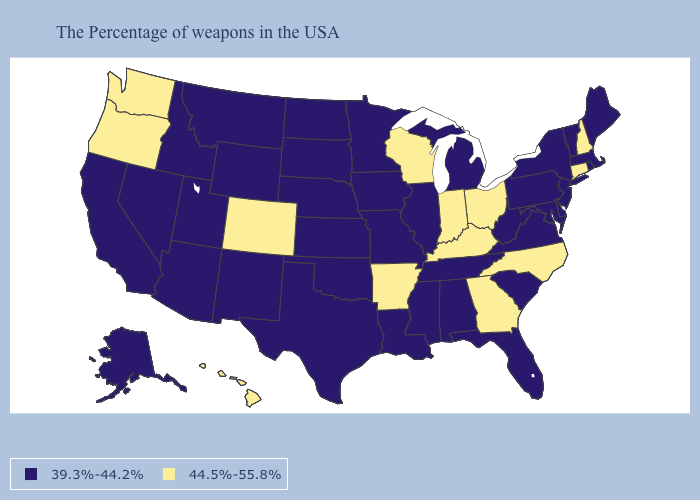What is the highest value in the Northeast ?
Give a very brief answer. 44.5%-55.8%. What is the highest value in states that border Texas?
Write a very short answer. 44.5%-55.8%. Which states have the highest value in the USA?
Keep it brief. New Hampshire, Connecticut, North Carolina, Ohio, Georgia, Kentucky, Indiana, Wisconsin, Arkansas, Colorado, Washington, Oregon, Hawaii. Which states have the highest value in the USA?
Be succinct. New Hampshire, Connecticut, North Carolina, Ohio, Georgia, Kentucky, Indiana, Wisconsin, Arkansas, Colorado, Washington, Oregon, Hawaii. What is the value of Arkansas?
Concise answer only. 44.5%-55.8%. Does Alabama have the highest value in the South?
Answer briefly. No. Among the states that border New Mexico , does Colorado have the lowest value?
Write a very short answer. No. What is the lowest value in states that border Rhode Island?
Short answer required. 39.3%-44.2%. What is the value of Alabama?
Short answer required. 39.3%-44.2%. Name the states that have a value in the range 44.5%-55.8%?
Short answer required. New Hampshire, Connecticut, North Carolina, Ohio, Georgia, Kentucky, Indiana, Wisconsin, Arkansas, Colorado, Washington, Oregon, Hawaii. What is the value of Florida?
Short answer required. 39.3%-44.2%. What is the highest value in the South ?
Answer briefly. 44.5%-55.8%. What is the value of Montana?
Short answer required. 39.3%-44.2%. Name the states that have a value in the range 39.3%-44.2%?
Short answer required. Maine, Massachusetts, Rhode Island, Vermont, New York, New Jersey, Delaware, Maryland, Pennsylvania, Virginia, South Carolina, West Virginia, Florida, Michigan, Alabama, Tennessee, Illinois, Mississippi, Louisiana, Missouri, Minnesota, Iowa, Kansas, Nebraska, Oklahoma, Texas, South Dakota, North Dakota, Wyoming, New Mexico, Utah, Montana, Arizona, Idaho, Nevada, California, Alaska. 